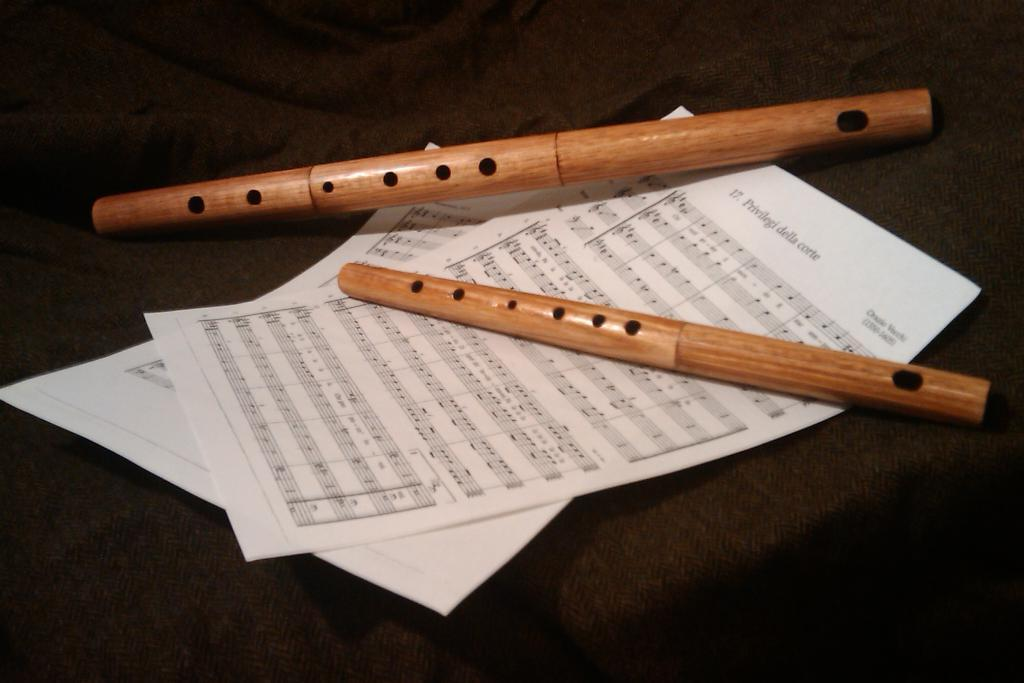What objects can be seen in the image? There are papers and flutes in the image. Can you describe the papers in the image? The provided facts do not give any specific details about the papers, so we cannot describe them further. How many flutes are visible in the image? The provided facts do not specify the number of flutes, so we cannot determine the exact number. What type of lamp is present in the image? There is no lamp present in the image. Can you describe the gate in the image? There is no gate present in the image. 